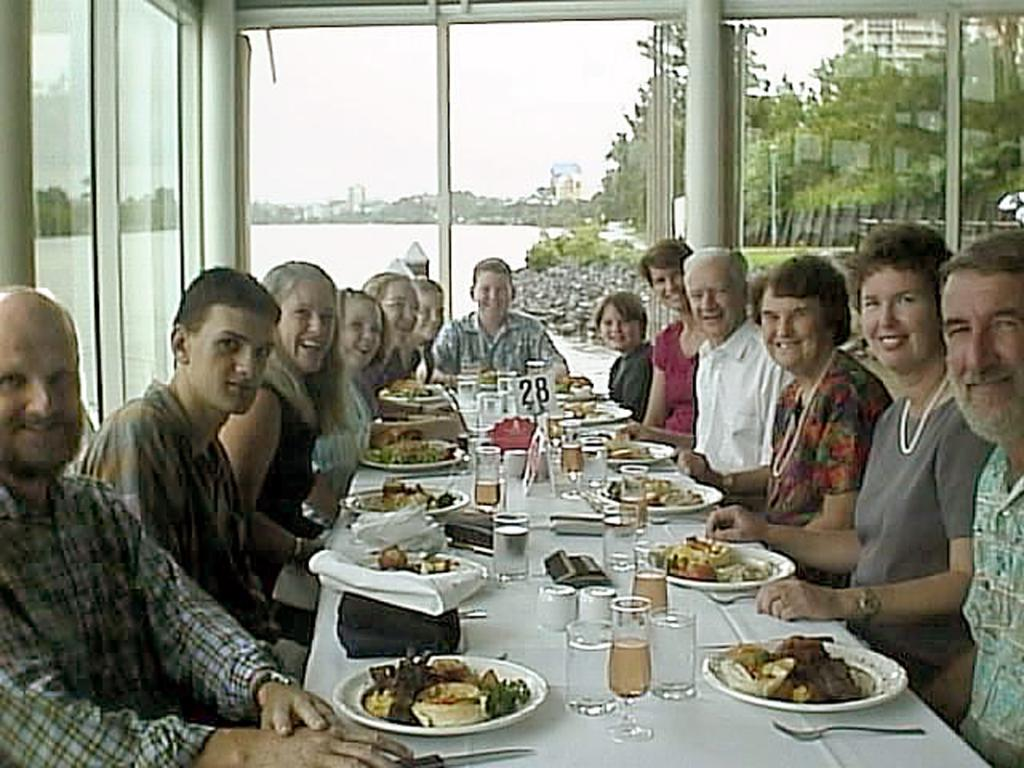How many persons are in the image? There are persons in the image, but the exact number is not specified. What are the persons wearing? The persons are wearing clothes. Where are the persons sitting in relation to the table? The persons are sitting in front of a table. What can be found on the table? The table contains glasses and plates with food. What is visible at the top of the image? The sky is visible at the top of the image. What type of nut is being used to operate the machine in the image? There is no machine or nut present in the image. 